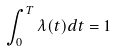Convert formula to latex. <formula><loc_0><loc_0><loc_500><loc_500>\int _ { 0 } ^ { T } \lambda ( t ) d t = 1</formula> 